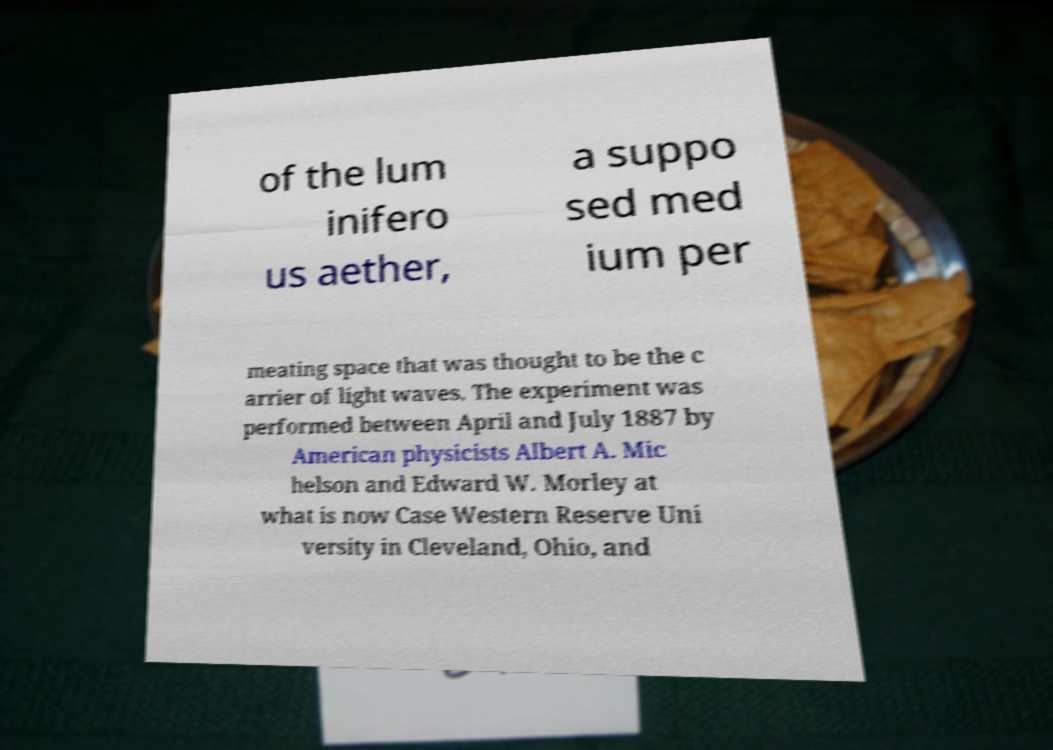What messages or text are displayed in this image? I need them in a readable, typed format. of the lum inifero us aether, a suppo sed med ium per meating space that was thought to be the c arrier of light waves. The experiment was performed between April and July 1887 by American physicists Albert A. Mic helson and Edward W. Morley at what is now Case Western Reserve Uni versity in Cleveland, Ohio, and 